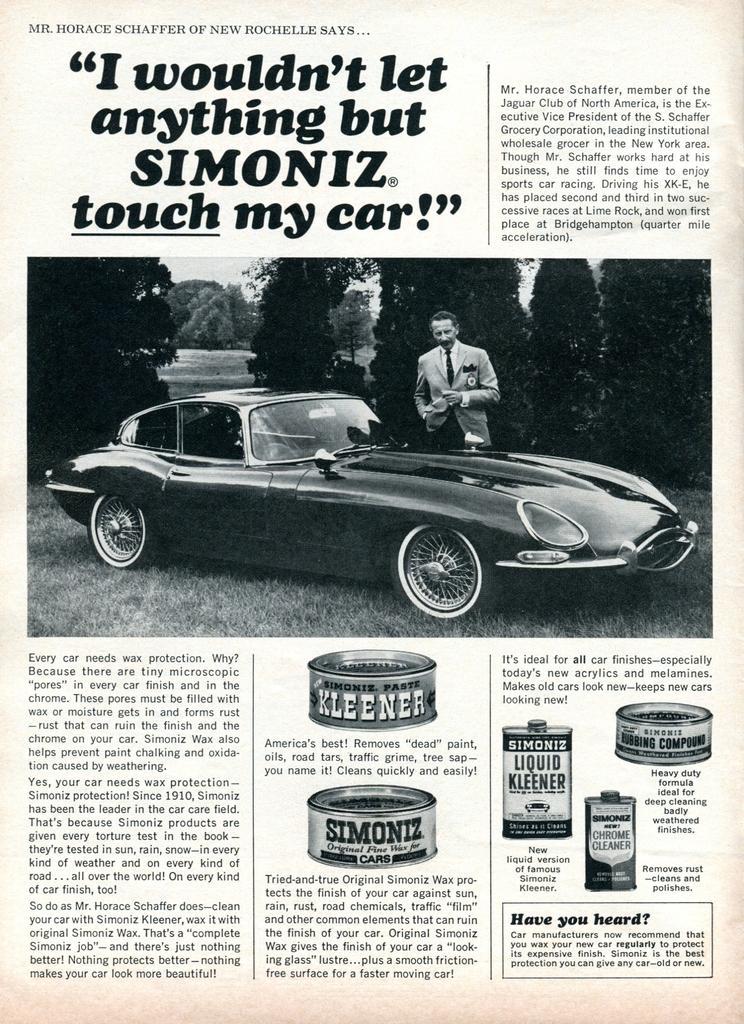Could you give a brief overview of what you see in this image? It is a poster. In this image there is a person standing in front of the car. At the bottom of the image there is grass on the surface. In the background of the image there are trees. There is text and some objects on the image. 